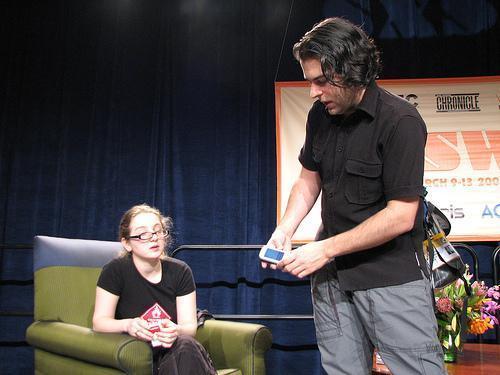How many people are in the photo?
Give a very brief answer. 2. How many pairs of eyeglasses are in the photo?
Give a very brief answer. 1. 